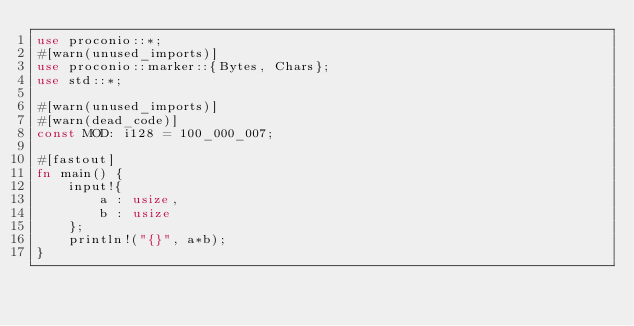Convert code to text. <code><loc_0><loc_0><loc_500><loc_500><_Rust_>use proconio::*;
#[warn(unused_imports)]
use proconio::marker::{Bytes, Chars};
use std::*;

#[warn(unused_imports)]
#[warn(dead_code)]
const MOD: i128 = 100_000_007;

#[fastout]
fn main() {
    input!{
        a : usize,
        b : usize
    };
    println!("{}", a*b);
}
</code> 